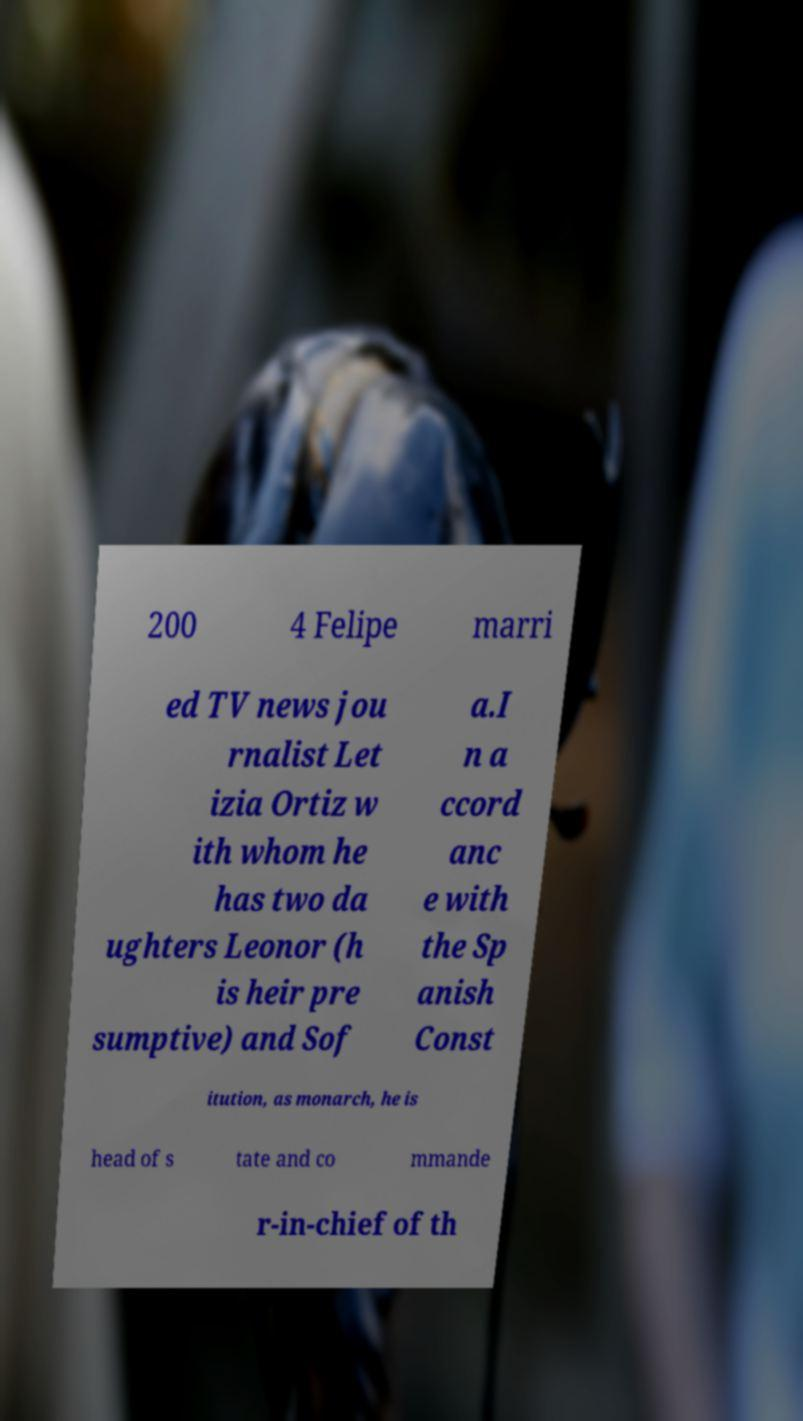Could you extract and type out the text from this image? 200 4 Felipe marri ed TV news jou rnalist Let izia Ortiz w ith whom he has two da ughters Leonor (h is heir pre sumptive) and Sof a.I n a ccord anc e with the Sp anish Const itution, as monarch, he is head of s tate and co mmande r-in-chief of th 